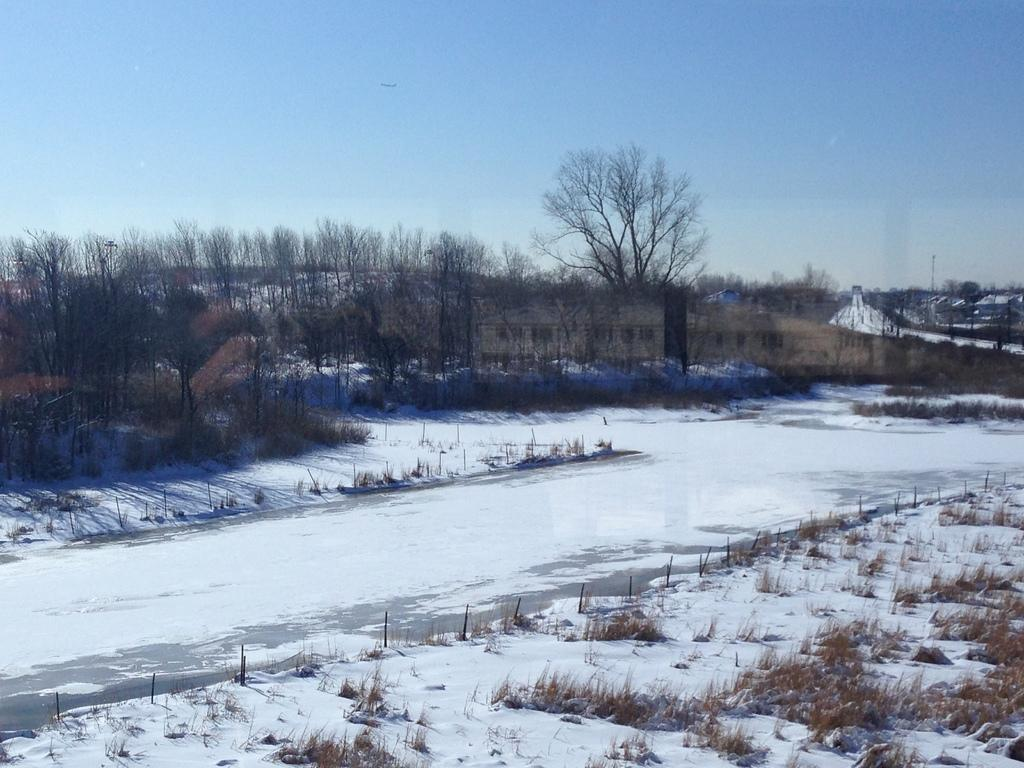What type of weather is depicted in the image? There is snow in the image, indicating a snowy or wintry weather. What type of vegetation can be seen in the image? There are trees in the image. What is visible in the sky in the image? The sky is visible in the image. What type of credit card is visible in the image? There is no credit card present in the image. How does the wire interact with the snow in the image? There is no wire present in the image. 